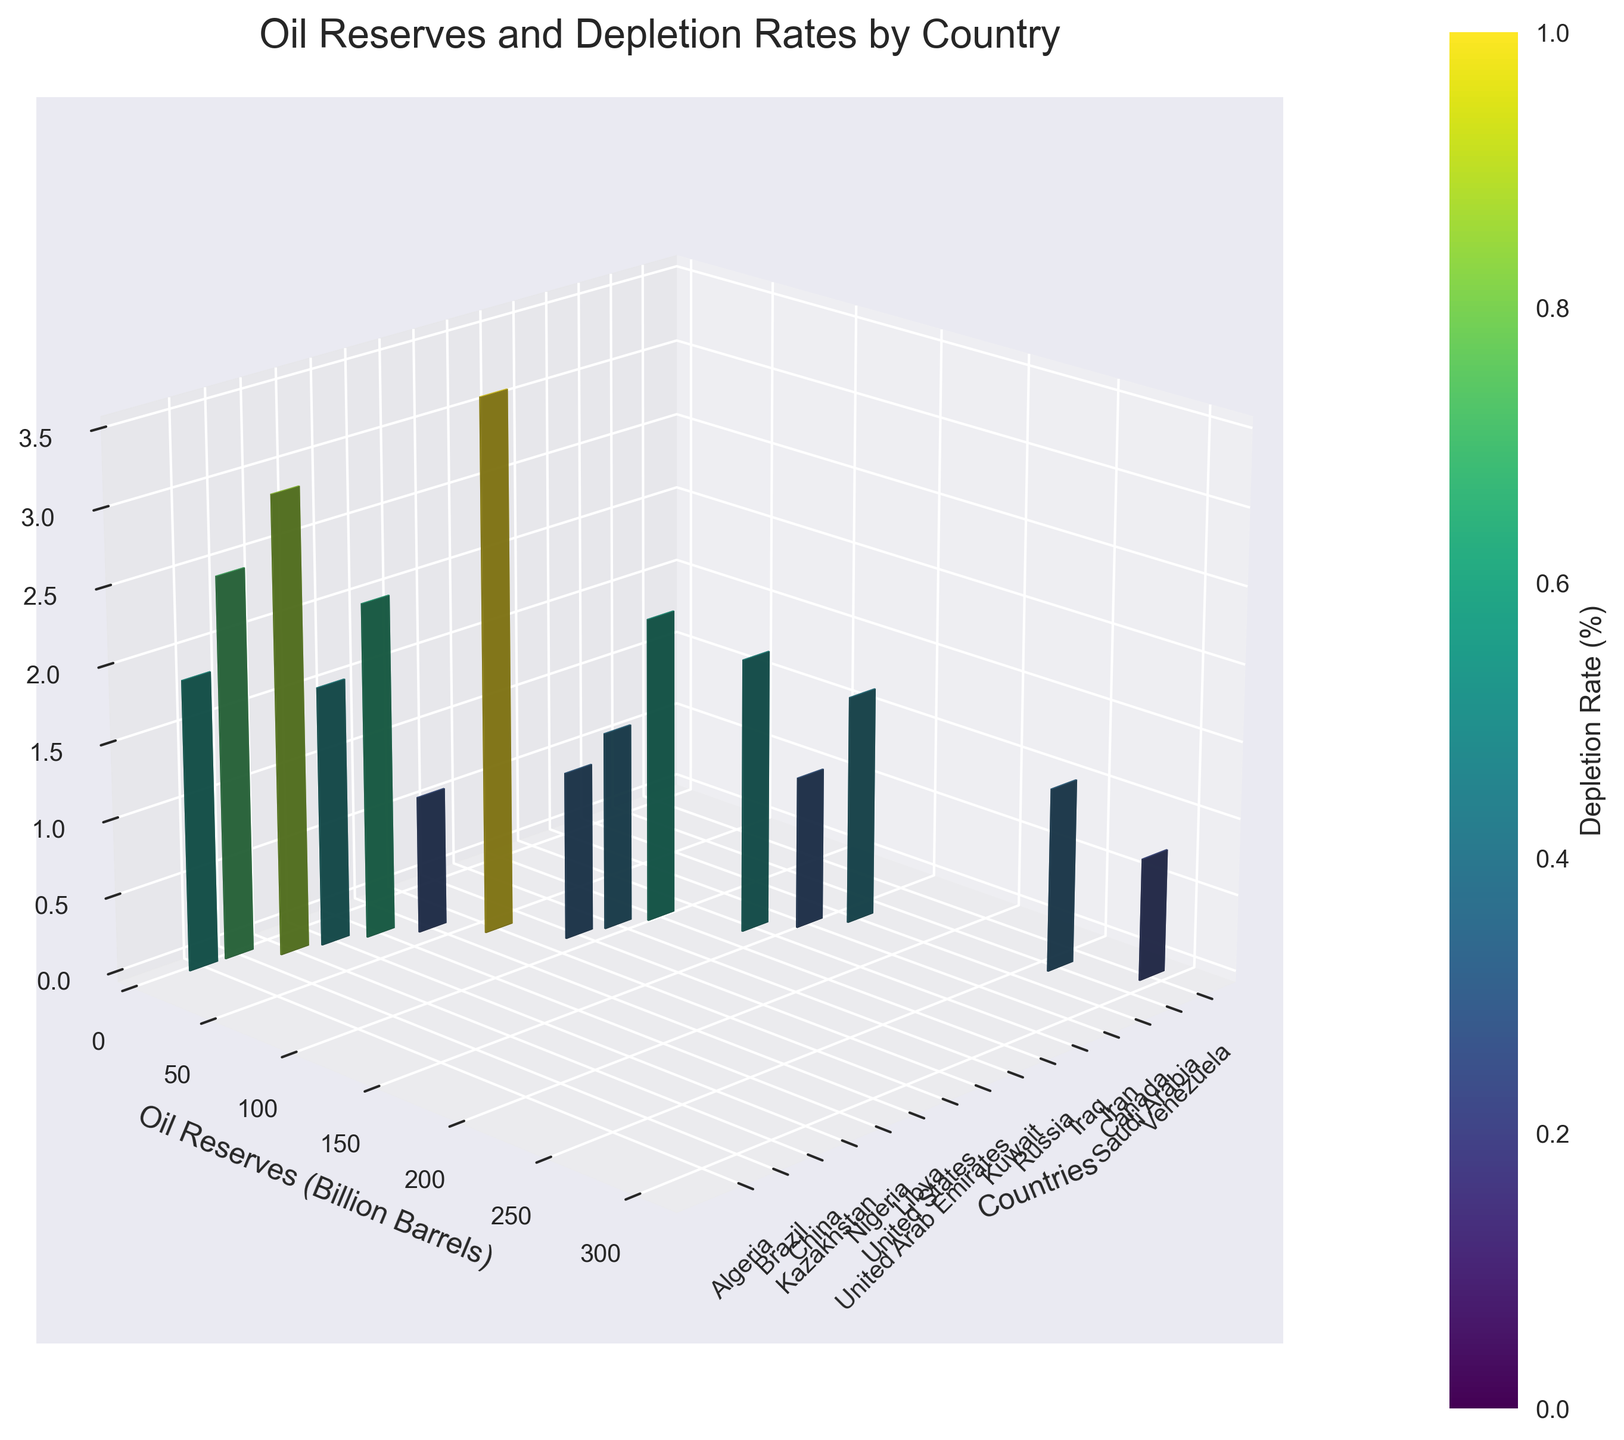What's the title of the figure? The title is usually displayed at the top of the figure in a larger font. Based on the code, the title of the figure is explicitly stated.
Answer: Oil Reserves and Depletion Rates by Country Which country has the highest oil reserves? To identify this, look for the tallest bar on the y-axis, which corresponds to the "Reserves" value. From the figure, the tallest bar is for Venezuela.
Answer: Venezuela What is the depletion rate of the United States? Find "United States" on the x-axis and check the height of its bar along the z-axis. The depletion rate for the United States will align with this bar.
Answer: 3.5% Which country has the highest depletion rate and what is its value? To determine this, find the tallest bar on the z-axis, which indicates the highest depletion rate. From the figure, the tallest z-axis bar corresponds to the United States.
Answer: United States, 3.5% Compare the oil reserves of Saudi Arabia and Canada. Locate both countries on the x-axis and compare their y-axis bars' heights. Saudi Arabia has a taller bar on the y-axis (Reserves) compared to Canada.
Answer: Saudi Arabia has higher reserves than Canada What is the total oil reserves for the top three countries with the highest reserves? Examine the y-axis bars and identify the top three countries: Venezuela, Saudi Arabia, and Canada. Add their reserves: 300.9 + 267.0 + 169.7.
Answer: 737.6 billion barrels Which country has the lowest depletion rate and what is its value? Identify the shortest bar on the z-axis, indicating the lowest depletion rate. The shortest bar aligns with Venezuela.
Answer: Venezuela, 0.8% Compare the depletion rates of Iran and Russia. Identify the bars for Iran and Russia on the x-axis and compare their z-axis heights. Russia has a higher depletion rate than Iran.
Answer: Russia has a higher depletion rate than Iran What's the sum of the oil reserves of the countries with depletion rates less than 1%? Identify countries with z-axis bars below 1%: Venezuela, Iran, and Libya. Sum their reserves: 300.9 + 158.4 + 48.4.
Answer: 507.7 billion barrels What is the average depletion rate for countries with more than 100 billion barrels of reserves? Identify countries with more than 100 billion barrels: Venezuela, Saudi Arabia, Canada, Iran, Iraq, and Russia. Calculate their mean depletion rate: (0.8 + 1.2 + 1.5 + 1.0 + 1.8 + 2.0) / 6.
Answer: 1.55% 